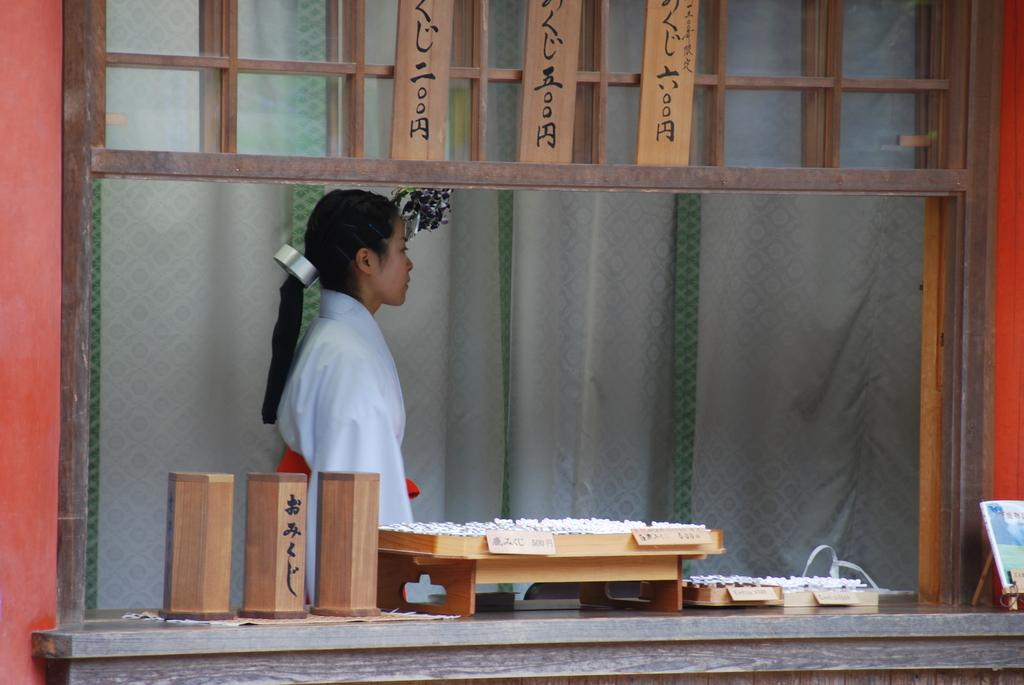What is the main subject of the image? The main subject of the image is a girl walking. What type of objects can be seen in the image? There are wooden objects in the image. What type of window treatment is present in the image? There are curtains in the image. What type of oatmeal is the girl eating in the image? There is no oatmeal present in the image, and the girl is not shown eating anything. What color are the girl's eyes in the image? The color of the girl's eyes cannot be determined from the image, as her eyes are not visible. 